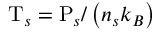Convert formula to latex. <formula><loc_0><loc_0><loc_500><loc_500>T _ { s } = P _ { s } / \left ( n _ { s } k _ { B } \right )</formula> 